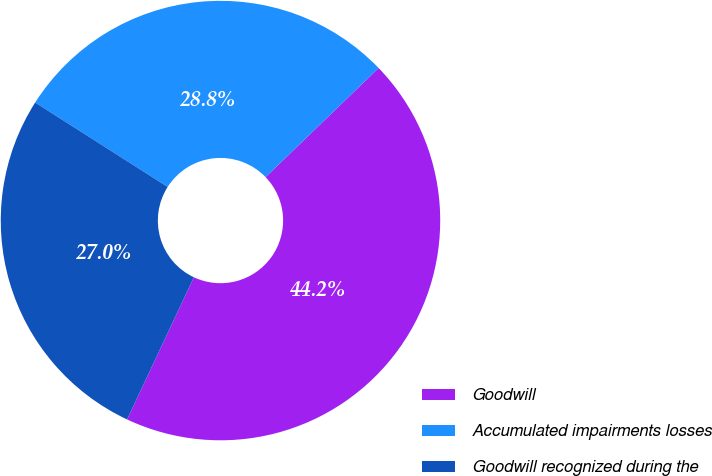<chart> <loc_0><loc_0><loc_500><loc_500><pie_chart><fcel>Goodwill<fcel>Accumulated impairments losses<fcel>Goodwill recognized during the<nl><fcel>44.2%<fcel>28.76%<fcel>27.04%<nl></chart> 